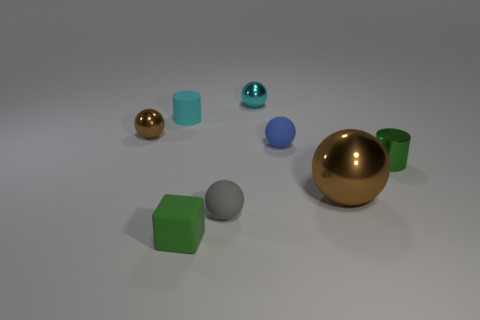There is a brown thing behind the brown object on the right side of the cyan rubber cylinder; what size is it?
Provide a succinct answer. Small. The large metal thing is what shape?
Offer a very short reply. Sphere. How many tiny objects are shiny objects or green blocks?
Your answer should be very brief. 4. There is another thing that is the same shape as the small cyan matte thing; what is its size?
Your answer should be very brief. Small. What number of small objects are both to the left of the metal cylinder and right of the gray ball?
Make the answer very short. 2. Does the gray thing have the same shape as the brown object that is on the right side of the small brown object?
Your answer should be very brief. Yes. Are there more brown objects right of the tiny cyan shiny sphere than small yellow cylinders?
Your answer should be compact. Yes. Is the number of cyan matte cylinders that are right of the tiny cube less than the number of blue matte objects?
Give a very brief answer. Yes. How many large shiny balls are the same color as the tiny cube?
Provide a short and direct response. 0. The small thing that is behind the tiny blue matte object and right of the small cube is made of what material?
Provide a succinct answer. Metal. 